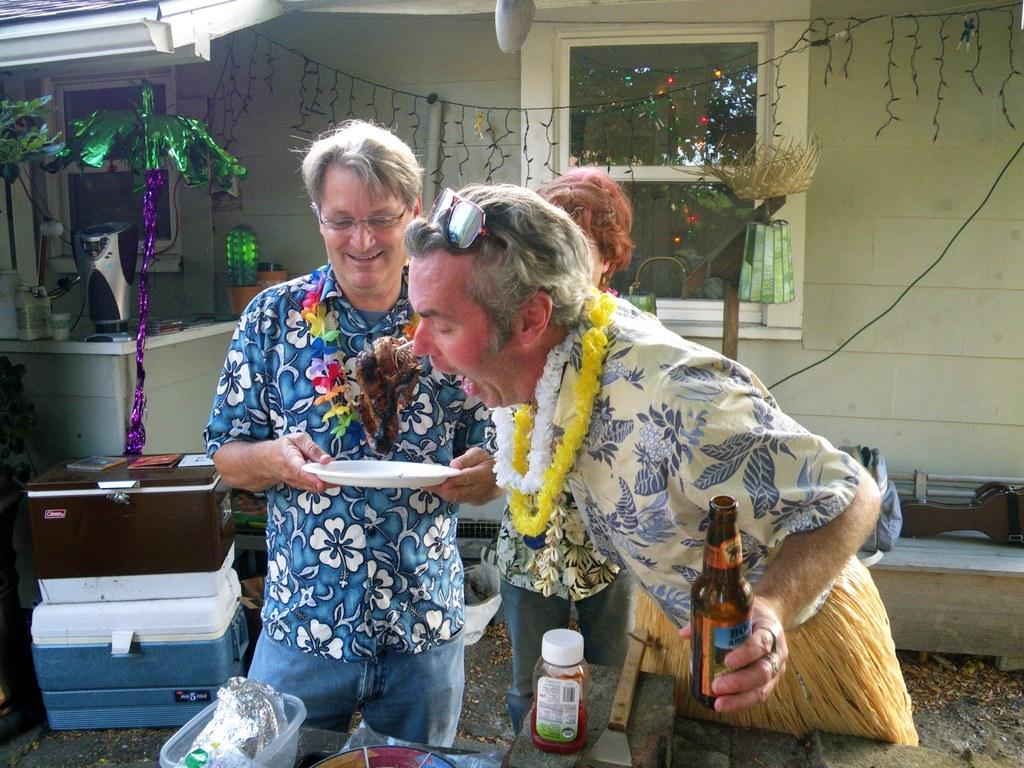How many people can be seen in the image? There are few people in the image. What are the people holding in the image? One person is holding a bottle, and another person is holding a plate. What can be seen in the background of the image? There is a house visible in the background. What other items are present in the image? There are objects and boxes placed in the image. What type of scarecrow can be seen sneezing in the image? There is no scarecrow or sneezing in the image; it features people holding a bottle and a plate, with a house visible in the background and objects and boxes placed in the image. 